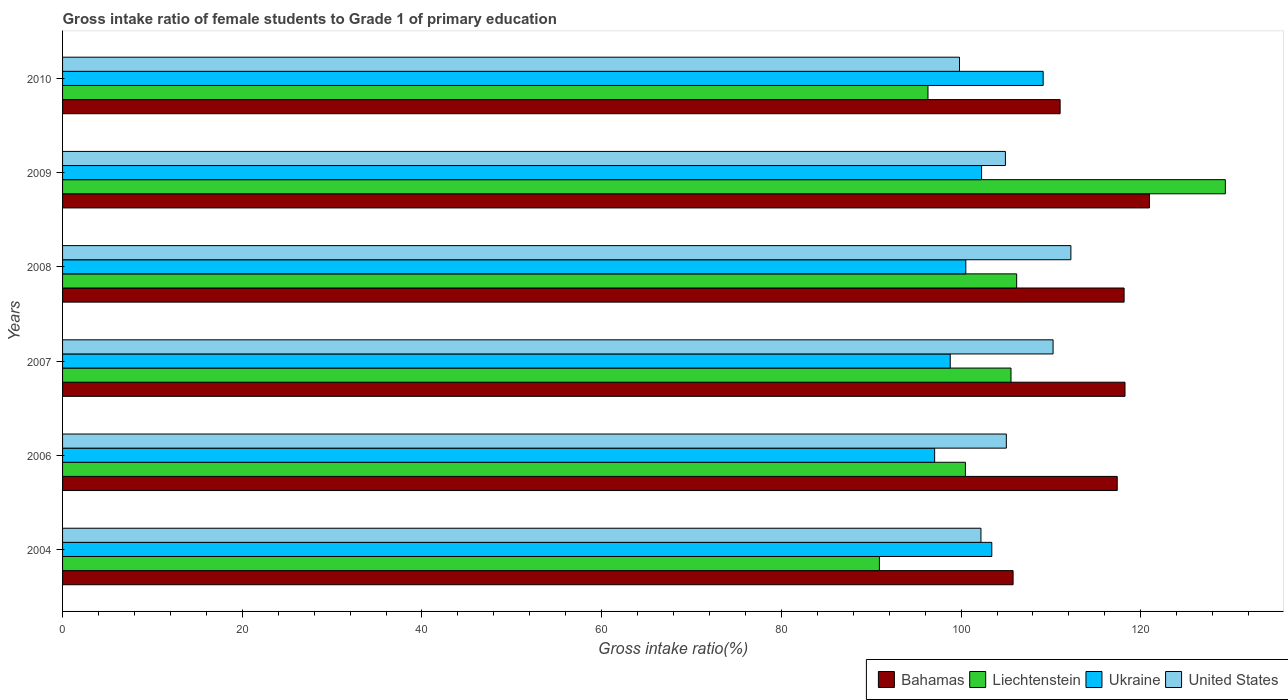How many groups of bars are there?
Your response must be concise. 6. Are the number of bars per tick equal to the number of legend labels?
Provide a short and direct response. Yes. What is the gross intake ratio in Bahamas in 2009?
Your answer should be very brief. 120.97. Across all years, what is the maximum gross intake ratio in Bahamas?
Make the answer very short. 120.97. Across all years, what is the minimum gross intake ratio in United States?
Give a very brief answer. 99.82. What is the total gross intake ratio in Ukraine in the graph?
Offer a very short reply. 611.21. What is the difference between the gross intake ratio in Bahamas in 2004 and that in 2008?
Offer a terse response. -12.35. What is the difference between the gross intake ratio in Ukraine in 2009 and the gross intake ratio in United States in 2008?
Ensure brevity in your answer.  -9.94. What is the average gross intake ratio in United States per year?
Offer a very short reply. 105.74. In the year 2010, what is the difference between the gross intake ratio in Liechtenstein and gross intake ratio in United States?
Offer a terse response. -3.51. What is the ratio of the gross intake ratio in Liechtenstein in 2009 to that in 2010?
Your answer should be compact. 1.34. Is the gross intake ratio in Bahamas in 2006 less than that in 2009?
Keep it short and to the point. Yes. Is the difference between the gross intake ratio in Liechtenstein in 2007 and 2010 greater than the difference between the gross intake ratio in United States in 2007 and 2010?
Give a very brief answer. No. What is the difference between the highest and the second highest gross intake ratio in Ukraine?
Your answer should be very brief. 5.72. What is the difference between the highest and the lowest gross intake ratio in Ukraine?
Keep it short and to the point. 12.08. Is it the case that in every year, the sum of the gross intake ratio in Bahamas and gross intake ratio in Liechtenstein is greater than the sum of gross intake ratio in United States and gross intake ratio in Ukraine?
Your answer should be compact. No. What does the 2nd bar from the top in 2007 represents?
Keep it short and to the point. Ukraine. What does the 3rd bar from the bottom in 2007 represents?
Provide a short and direct response. Ukraine. Is it the case that in every year, the sum of the gross intake ratio in Liechtenstein and gross intake ratio in United States is greater than the gross intake ratio in Bahamas?
Provide a short and direct response. Yes. How many bars are there?
Ensure brevity in your answer.  24. Are all the bars in the graph horizontal?
Give a very brief answer. Yes. Does the graph contain any zero values?
Your response must be concise. No. How many legend labels are there?
Make the answer very short. 4. How are the legend labels stacked?
Your response must be concise. Horizontal. What is the title of the graph?
Offer a very short reply. Gross intake ratio of female students to Grade 1 of primary education. What is the label or title of the X-axis?
Provide a succinct answer. Gross intake ratio(%). What is the label or title of the Y-axis?
Your answer should be compact. Years. What is the Gross intake ratio(%) in Bahamas in 2004?
Give a very brief answer. 105.79. What is the Gross intake ratio(%) of Liechtenstein in 2004?
Provide a short and direct response. 90.91. What is the Gross intake ratio(%) in Ukraine in 2004?
Offer a terse response. 103.42. What is the Gross intake ratio(%) in United States in 2004?
Your answer should be compact. 102.21. What is the Gross intake ratio(%) of Bahamas in 2006?
Offer a terse response. 117.38. What is the Gross intake ratio(%) of Liechtenstein in 2006?
Offer a very short reply. 100.48. What is the Gross intake ratio(%) in Ukraine in 2006?
Keep it short and to the point. 97.06. What is the Gross intake ratio(%) of United States in 2006?
Your answer should be very brief. 105.04. What is the Gross intake ratio(%) in Bahamas in 2007?
Your answer should be very brief. 118.24. What is the Gross intake ratio(%) of Liechtenstein in 2007?
Offer a very short reply. 105.56. What is the Gross intake ratio(%) of Ukraine in 2007?
Provide a short and direct response. 98.79. What is the Gross intake ratio(%) of United States in 2007?
Your answer should be compact. 110.24. What is the Gross intake ratio(%) in Bahamas in 2008?
Offer a terse response. 118.14. What is the Gross intake ratio(%) in Liechtenstein in 2008?
Provide a succinct answer. 106.19. What is the Gross intake ratio(%) in Ukraine in 2008?
Keep it short and to the point. 100.53. What is the Gross intake ratio(%) of United States in 2008?
Offer a very short reply. 112.22. What is the Gross intake ratio(%) in Bahamas in 2009?
Make the answer very short. 120.97. What is the Gross intake ratio(%) of Liechtenstein in 2009?
Your answer should be compact. 129.41. What is the Gross intake ratio(%) in Ukraine in 2009?
Provide a short and direct response. 102.28. What is the Gross intake ratio(%) of United States in 2009?
Make the answer very short. 104.94. What is the Gross intake ratio(%) of Bahamas in 2010?
Make the answer very short. 111.02. What is the Gross intake ratio(%) in Liechtenstein in 2010?
Provide a short and direct response. 96.32. What is the Gross intake ratio(%) of Ukraine in 2010?
Provide a short and direct response. 109.14. What is the Gross intake ratio(%) of United States in 2010?
Offer a terse response. 99.82. Across all years, what is the maximum Gross intake ratio(%) in Bahamas?
Your answer should be compact. 120.97. Across all years, what is the maximum Gross intake ratio(%) in Liechtenstein?
Keep it short and to the point. 129.41. Across all years, what is the maximum Gross intake ratio(%) of Ukraine?
Make the answer very short. 109.14. Across all years, what is the maximum Gross intake ratio(%) in United States?
Your answer should be compact. 112.22. Across all years, what is the minimum Gross intake ratio(%) of Bahamas?
Offer a terse response. 105.79. Across all years, what is the minimum Gross intake ratio(%) in Liechtenstein?
Provide a short and direct response. 90.91. Across all years, what is the minimum Gross intake ratio(%) of Ukraine?
Ensure brevity in your answer.  97.06. Across all years, what is the minimum Gross intake ratio(%) in United States?
Give a very brief answer. 99.82. What is the total Gross intake ratio(%) of Bahamas in the graph?
Offer a very short reply. 691.54. What is the total Gross intake ratio(%) of Liechtenstein in the graph?
Give a very brief answer. 628.86. What is the total Gross intake ratio(%) of Ukraine in the graph?
Keep it short and to the point. 611.21. What is the total Gross intake ratio(%) of United States in the graph?
Give a very brief answer. 634.47. What is the difference between the Gross intake ratio(%) in Bahamas in 2004 and that in 2006?
Your answer should be very brief. -11.59. What is the difference between the Gross intake ratio(%) in Liechtenstein in 2004 and that in 2006?
Your response must be concise. -9.57. What is the difference between the Gross intake ratio(%) of Ukraine in 2004 and that in 2006?
Your answer should be very brief. 6.36. What is the difference between the Gross intake ratio(%) in United States in 2004 and that in 2006?
Provide a short and direct response. -2.82. What is the difference between the Gross intake ratio(%) in Bahamas in 2004 and that in 2007?
Offer a terse response. -12.46. What is the difference between the Gross intake ratio(%) in Liechtenstein in 2004 and that in 2007?
Your response must be concise. -14.65. What is the difference between the Gross intake ratio(%) in Ukraine in 2004 and that in 2007?
Provide a short and direct response. 4.63. What is the difference between the Gross intake ratio(%) in United States in 2004 and that in 2007?
Provide a short and direct response. -8.03. What is the difference between the Gross intake ratio(%) in Bahamas in 2004 and that in 2008?
Provide a succinct answer. -12.36. What is the difference between the Gross intake ratio(%) in Liechtenstein in 2004 and that in 2008?
Your answer should be very brief. -15.28. What is the difference between the Gross intake ratio(%) of Ukraine in 2004 and that in 2008?
Provide a short and direct response. 2.89. What is the difference between the Gross intake ratio(%) in United States in 2004 and that in 2008?
Make the answer very short. -10.01. What is the difference between the Gross intake ratio(%) in Bahamas in 2004 and that in 2009?
Your answer should be compact. -15.18. What is the difference between the Gross intake ratio(%) in Liechtenstein in 2004 and that in 2009?
Your response must be concise. -38.5. What is the difference between the Gross intake ratio(%) in Ukraine in 2004 and that in 2009?
Give a very brief answer. 1.14. What is the difference between the Gross intake ratio(%) of United States in 2004 and that in 2009?
Give a very brief answer. -2.72. What is the difference between the Gross intake ratio(%) of Bahamas in 2004 and that in 2010?
Give a very brief answer. -5.24. What is the difference between the Gross intake ratio(%) of Liechtenstein in 2004 and that in 2010?
Keep it short and to the point. -5.41. What is the difference between the Gross intake ratio(%) in Ukraine in 2004 and that in 2010?
Your answer should be compact. -5.72. What is the difference between the Gross intake ratio(%) in United States in 2004 and that in 2010?
Your response must be concise. 2.39. What is the difference between the Gross intake ratio(%) of Bahamas in 2006 and that in 2007?
Give a very brief answer. -0.87. What is the difference between the Gross intake ratio(%) of Liechtenstein in 2006 and that in 2007?
Give a very brief answer. -5.07. What is the difference between the Gross intake ratio(%) in Ukraine in 2006 and that in 2007?
Give a very brief answer. -1.74. What is the difference between the Gross intake ratio(%) of United States in 2006 and that in 2007?
Keep it short and to the point. -5.2. What is the difference between the Gross intake ratio(%) in Bahamas in 2006 and that in 2008?
Your response must be concise. -0.76. What is the difference between the Gross intake ratio(%) in Liechtenstein in 2006 and that in 2008?
Provide a succinct answer. -5.7. What is the difference between the Gross intake ratio(%) in Ukraine in 2006 and that in 2008?
Give a very brief answer. -3.47. What is the difference between the Gross intake ratio(%) of United States in 2006 and that in 2008?
Make the answer very short. -7.18. What is the difference between the Gross intake ratio(%) in Bahamas in 2006 and that in 2009?
Your answer should be very brief. -3.59. What is the difference between the Gross intake ratio(%) of Liechtenstein in 2006 and that in 2009?
Offer a very short reply. -28.93. What is the difference between the Gross intake ratio(%) in Ukraine in 2006 and that in 2009?
Your response must be concise. -5.23. What is the difference between the Gross intake ratio(%) of United States in 2006 and that in 2009?
Your answer should be compact. 0.1. What is the difference between the Gross intake ratio(%) of Bahamas in 2006 and that in 2010?
Your response must be concise. 6.35. What is the difference between the Gross intake ratio(%) in Liechtenstein in 2006 and that in 2010?
Make the answer very short. 4.17. What is the difference between the Gross intake ratio(%) of Ukraine in 2006 and that in 2010?
Offer a terse response. -12.08. What is the difference between the Gross intake ratio(%) of United States in 2006 and that in 2010?
Your response must be concise. 5.21. What is the difference between the Gross intake ratio(%) in Bahamas in 2007 and that in 2008?
Provide a succinct answer. 0.1. What is the difference between the Gross intake ratio(%) in Liechtenstein in 2007 and that in 2008?
Make the answer very short. -0.63. What is the difference between the Gross intake ratio(%) of Ukraine in 2007 and that in 2008?
Make the answer very short. -1.73. What is the difference between the Gross intake ratio(%) in United States in 2007 and that in 2008?
Offer a terse response. -1.98. What is the difference between the Gross intake ratio(%) of Bahamas in 2007 and that in 2009?
Your answer should be very brief. -2.72. What is the difference between the Gross intake ratio(%) in Liechtenstein in 2007 and that in 2009?
Provide a short and direct response. -23.86. What is the difference between the Gross intake ratio(%) in Ukraine in 2007 and that in 2009?
Offer a very short reply. -3.49. What is the difference between the Gross intake ratio(%) of United States in 2007 and that in 2009?
Provide a succinct answer. 5.3. What is the difference between the Gross intake ratio(%) in Bahamas in 2007 and that in 2010?
Give a very brief answer. 7.22. What is the difference between the Gross intake ratio(%) of Liechtenstein in 2007 and that in 2010?
Give a very brief answer. 9.24. What is the difference between the Gross intake ratio(%) of Ukraine in 2007 and that in 2010?
Your answer should be very brief. -10.34. What is the difference between the Gross intake ratio(%) in United States in 2007 and that in 2010?
Provide a short and direct response. 10.41. What is the difference between the Gross intake ratio(%) in Bahamas in 2008 and that in 2009?
Give a very brief answer. -2.82. What is the difference between the Gross intake ratio(%) in Liechtenstein in 2008 and that in 2009?
Provide a succinct answer. -23.23. What is the difference between the Gross intake ratio(%) in Ukraine in 2008 and that in 2009?
Offer a terse response. -1.75. What is the difference between the Gross intake ratio(%) in United States in 2008 and that in 2009?
Provide a succinct answer. 7.29. What is the difference between the Gross intake ratio(%) of Bahamas in 2008 and that in 2010?
Give a very brief answer. 7.12. What is the difference between the Gross intake ratio(%) of Liechtenstein in 2008 and that in 2010?
Offer a terse response. 9.87. What is the difference between the Gross intake ratio(%) of Ukraine in 2008 and that in 2010?
Provide a succinct answer. -8.61. What is the difference between the Gross intake ratio(%) of United States in 2008 and that in 2010?
Your response must be concise. 12.4. What is the difference between the Gross intake ratio(%) in Bahamas in 2009 and that in 2010?
Your answer should be compact. 9.94. What is the difference between the Gross intake ratio(%) of Liechtenstein in 2009 and that in 2010?
Your answer should be very brief. 33.1. What is the difference between the Gross intake ratio(%) in Ukraine in 2009 and that in 2010?
Offer a terse response. -6.85. What is the difference between the Gross intake ratio(%) in United States in 2009 and that in 2010?
Keep it short and to the point. 5.11. What is the difference between the Gross intake ratio(%) of Bahamas in 2004 and the Gross intake ratio(%) of Liechtenstein in 2006?
Your answer should be compact. 5.3. What is the difference between the Gross intake ratio(%) in Bahamas in 2004 and the Gross intake ratio(%) in Ukraine in 2006?
Your answer should be compact. 8.73. What is the difference between the Gross intake ratio(%) in Bahamas in 2004 and the Gross intake ratio(%) in United States in 2006?
Provide a succinct answer. 0.75. What is the difference between the Gross intake ratio(%) in Liechtenstein in 2004 and the Gross intake ratio(%) in Ukraine in 2006?
Make the answer very short. -6.15. What is the difference between the Gross intake ratio(%) of Liechtenstein in 2004 and the Gross intake ratio(%) of United States in 2006?
Your answer should be compact. -14.13. What is the difference between the Gross intake ratio(%) in Ukraine in 2004 and the Gross intake ratio(%) in United States in 2006?
Provide a short and direct response. -1.62. What is the difference between the Gross intake ratio(%) of Bahamas in 2004 and the Gross intake ratio(%) of Liechtenstein in 2007?
Give a very brief answer. 0.23. What is the difference between the Gross intake ratio(%) of Bahamas in 2004 and the Gross intake ratio(%) of Ukraine in 2007?
Your response must be concise. 6.99. What is the difference between the Gross intake ratio(%) of Bahamas in 2004 and the Gross intake ratio(%) of United States in 2007?
Offer a very short reply. -4.45. What is the difference between the Gross intake ratio(%) of Liechtenstein in 2004 and the Gross intake ratio(%) of Ukraine in 2007?
Offer a very short reply. -7.88. What is the difference between the Gross intake ratio(%) in Liechtenstein in 2004 and the Gross intake ratio(%) in United States in 2007?
Your answer should be very brief. -19.33. What is the difference between the Gross intake ratio(%) in Ukraine in 2004 and the Gross intake ratio(%) in United States in 2007?
Ensure brevity in your answer.  -6.82. What is the difference between the Gross intake ratio(%) in Bahamas in 2004 and the Gross intake ratio(%) in Liechtenstein in 2008?
Ensure brevity in your answer.  -0.4. What is the difference between the Gross intake ratio(%) of Bahamas in 2004 and the Gross intake ratio(%) of Ukraine in 2008?
Offer a terse response. 5.26. What is the difference between the Gross intake ratio(%) in Bahamas in 2004 and the Gross intake ratio(%) in United States in 2008?
Keep it short and to the point. -6.43. What is the difference between the Gross intake ratio(%) in Liechtenstein in 2004 and the Gross intake ratio(%) in Ukraine in 2008?
Offer a terse response. -9.62. What is the difference between the Gross intake ratio(%) of Liechtenstein in 2004 and the Gross intake ratio(%) of United States in 2008?
Keep it short and to the point. -21.31. What is the difference between the Gross intake ratio(%) of Ukraine in 2004 and the Gross intake ratio(%) of United States in 2008?
Your answer should be very brief. -8.8. What is the difference between the Gross intake ratio(%) of Bahamas in 2004 and the Gross intake ratio(%) of Liechtenstein in 2009?
Your answer should be very brief. -23.62. What is the difference between the Gross intake ratio(%) of Bahamas in 2004 and the Gross intake ratio(%) of Ukraine in 2009?
Your answer should be very brief. 3.51. What is the difference between the Gross intake ratio(%) of Bahamas in 2004 and the Gross intake ratio(%) of United States in 2009?
Your answer should be very brief. 0.85. What is the difference between the Gross intake ratio(%) of Liechtenstein in 2004 and the Gross intake ratio(%) of Ukraine in 2009?
Your answer should be compact. -11.37. What is the difference between the Gross intake ratio(%) in Liechtenstein in 2004 and the Gross intake ratio(%) in United States in 2009?
Provide a short and direct response. -14.03. What is the difference between the Gross intake ratio(%) in Ukraine in 2004 and the Gross intake ratio(%) in United States in 2009?
Your answer should be compact. -1.52. What is the difference between the Gross intake ratio(%) of Bahamas in 2004 and the Gross intake ratio(%) of Liechtenstein in 2010?
Your answer should be compact. 9.47. What is the difference between the Gross intake ratio(%) in Bahamas in 2004 and the Gross intake ratio(%) in Ukraine in 2010?
Offer a very short reply. -3.35. What is the difference between the Gross intake ratio(%) in Bahamas in 2004 and the Gross intake ratio(%) in United States in 2010?
Offer a very short reply. 5.96. What is the difference between the Gross intake ratio(%) in Liechtenstein in 2004 and the Gross intake ratio(%) in Ukraine in 2010?
Provide a short and direct response. -18.23. What is the difference between the Gross intake ratio(%) in Liechtenstein in 2004 and the Gross intake ratio(%) in United States in 2010?
Your answer should be very brief. -8.91. What is the difference between the Gross intake ratio(%) in Ukraine in 2004 and the Gross intake ratio(%) in United States in 2010?
Your answer should be very brief. 3.6. What is the difference between the Gross intake ratio(%) in Bahamas in 2006 and the Gross intake ratio(%) in Liechtenstein in 2007?
Your answer should be compact. 11.82. What is the difference between the Gross intake ratio(%) of Bahamas in 2006 and the Gross intake ratio(%) of Ukraine in 2007?
Offer a very short reply. 18.58. What is the difference between the Gross intake ratio(%) of Bahamas in 2006 and the Gross intake ratio(%) of United States in 2007?
Offer a terse response. 7.14. What is the difference between the Gross intake ratio(%) of Liechtenstein in 2006 and the Gross intake ratio(%) of Ukraine in 2007?
Make the answer very short. 1.69. What is the difference between the Gross intake ratio(%) of Liechtenstein in 2006 and the Gross intake ratio(%) of United States in 2007?
Your response must be concise. -9.76. What is the difference between the Gross intake ratio(%) in Ukraine in 2006 and the Gross intake ratio(%) in United States in 2007?
Offer a very short reply. -13.18. What is the difference between the Gross intake ratio(%) of Bahamas in 2006 and the Gross intake ratio(%) of Liechtenstein in 2008?
Keep it short and to the point. 11.19. What is the difference between the Gross intake ratio(%) of Bahamas in 2006 and the Gross intake ratio(%) of Ukraine in 2008?
Offer a very short reply. 16.85. What is the difference between the Gross intake ratio(%) of Bahamas in 2006 and the Gross intake ratio(%) of United States in 2008?
Offer a very short reply. 5.16. What is the difference between the Gross intake ratio(%) in Liechtenstein in 2006 and the Gross intake ratio(%) in Ukraine in 2008?
Offer a terse response. -0.04. What is the difference between the Gross intake ratio(%) of Liechtenstein in 2006 and the Gross intake ratio(%) of United States in 2008?
Provide a short and direct response. -11.74. What is the difference between the Gross intake ratio(%) in Ukraine in 2006 and the Gross intake ratio(%) in United States in 2008?
Your answer should be very brief. -15.16. What is the difference between the Gross intake ratio(%) in Bahamas in 2006 and the Gross intake ratio(%) in Liechtenstein in 2009?
Offer a very short reply. -12.03. What is the difference between the Gross intake ratio(%) in Bahamas in 2006 and the Gross intake ratio(%) in Ukraine in 2009?
Give a very brief answer. 15.1. What is the difference between the Gross intake ratio(%) of Bahamas in 2006 and the Gross intake ratio(%) of United States in 2009?
Offer a very short reply. 12.44. What is the difference between the Gross intake ratio(%) in Liechtenstein in 2006 and the Gross intake ratio(%) in Ukraine in 2009?
Keep it short and to the point. -1.8. What is the difference between the Gross intake ratio(%) in Liechtenstein in 2006 and the Gross intake ratio(%) in United States in 2009?
Give a very brief answer. -4.45. What is the difference between the Gross intake ratio(%) of Ukraine in 2006 and the Gross intake ratio(%) of United States in 2009?
Your response must be concise. -7.88. What is the difference between the Gross intake ratio(%) in Bahamas in 2006 and the Gross intake ratio(%) in Liechtenstein in 2010?
Provide a succinct answer. 21.06. What is the difference between the Gross intake ratio(%) of Bahamas in 2006 and the Gross intake ratio(%) of Ukraine in 2010?
Your answer should be compact. 8.24. What is the difference between the Gross intake ratio(%) of Bahamas in 2006 and the Gross intake ratio(%) of United States in 2010?
Keep it short and to the point. 17.55. What is the difference between the Gross intake ratio(%) in Liechtenstein in 2006 and the Gross intake ratio(%) in Ukraine in 2010?
Ensure brevity in your answer.  -8.65. What is the difference between the Gross intake ratio(%) in Liechtenstein in 2006 and the Gross intake ratio(%) in United States in 2010?
Ensure brevity in your answer.  0.66. What is the difference between the Gross intake ratio(%) in Ukraine in 2006 and the Gross intake ratio(%) in United States in 2010?
Your answer should be compact. -2.77. What is the difference between the Gross intake ratio(%) in Bahamas in 2007 and the Gross intake ratio(%) in Liechtenstein in 2008?
Provide a short and direct response. 12.06. What is the difference between the Gross intake ratio(%) in Bahamas in 2007 and the Gross intake ratio(%) in Ukraine in 2008?
Ensure brevity in your answer.  17.72. What is the difference between the Gross intake ratio(%) in Bahamas in 2007 and the Gross intake ratio(%) in United States in 2008?
Keep it short and to the point. 6.02. What is the difference between the Gross intake ratio(%) in Liechtenstein in 2007 and the Gross intake ratio(%) in Ukraine in 2008?
Provide a succinct answer. 5.03. What is the difference between the Gross intake ratio(%) in Liechtenstein in 2007 and the Gross intake ratio(%) in United States in 2008?
Ensure brevity in your answer.  -6.67. What is the difference between the Gross intake ratio(%) of Ukraine in 2007 and the Gross intake ratio(%) of United States in 2008?
Offer a terse response. -13.43. What is the difference between the Gross intake ratio(%) in Bahamas in 2007 and the Gross intake ratio(%) in Liechtenstein in 2009?
Give a very brief answer. -11.17. What is the difference between the Gross intake ratio(%) of Bahamas in 2007 and the Gross intake ratio(%) of Ukraine in 2009?
Give a very brief answer. 15.96. What is the difference between the Gross intake ratio(%) of Bahamas in 2007 and the Gross intake ratio(%) of United States in 2009?
Your answer should be compact. 13.31. What is the difference between the Gross intake ratio(%) of Liechtenstein in 2007 and the Gross intake ratio(%) of Ukraine in 2009?
Make the answer very short. 3.27. What is the difference between the Gross intake ratio(%) in Liechtenstein in 2007 and the Gross intake ratio(%) in United States in 2009?
Keep it short and to the point. 0.62. What is the difference between the Gross intake ratio(%) of Ukraine in 2007 and the Gross intake ratio(%) of United States in 2009?
Make the answer very short. -6.14. What is the difference between the Gross intake ratio(%) in Bahamas in 2007 and the Gross intake ratio(%) in Liechtenstein in 2010?
Your response must be concise. 21.93. What is the difference between the Gross intake ratio(%) in Bahamas in 2007 and the Gross intake ratio(%) in Ukraine in 2010?
Make the answer very short. 9.11. What is the difference between the Gross intake ratio(%) of Bahamas in 2007 and the Gross intake ratio(%) of United States in 2010?
Ensure brevity in your answer.  18.42. What is the difference between the Gross intake ratio(%) in Liechtenstein in 2007 and the Gross intake ratio(%) in Ukraine in 2010?
Provide a short and direct response. -3.58. What is the difference between the Gross intake ratio(%) of Liechtenstein in 2007 and the Gross intake ratio(%) of United States in 2010?
Your answer should be compact. 5.73. What is the difference between the Gross intake ratio(%) in Ukraine in 2007 and the Gross intake ratio(%) in United States in 2010?
Make the answer very short. -1.03. What is the difference between the Gross intake ratio(%) of Bahamas in 2008 and the Gross intake ratio(%) of Liechtenstein in 2009?
Offer a very short reply. -11.27. What is the difference between the Gross intake ratio(%) of Bahamas in 2008 and the Gross intake ratio(%) of Ukraine in 2009?
Your answer should be compact. 15.86. What is the difference between the Gross intake ratio(%) in Bahamas in 2008 and the Gross intake ratio(%) in United States in 2009?
Your answer should be compact. 13.21. What is the difference between the Gross intake ratio(%) of Liechtenstein in 2008 and the Gross intake ratio(%) of Ukraine in 2009?
Provide a succinct answer. 3.9. What is the difference between the Gross intake ratio(%) of Liechtenstein in 2008 and the Gross intake ratio(%) of United States in 2009?
Keep it short and to the point. 1.25. What is the difference between the Gross intake ratio(%) in Ukraine in 2008 and the Gross intake ratio(%) in United States in 2009?
Give a very brief answer. -4.41. What is the difference between the Gross intake ratio(%) of Bahamas in 2008 and the Gross intake ratio(%) of Liechtenstein in 2010?
Make the answer very short. 21.83. What is the difference between the Gross intake ratio(%) of Bahamas in 2008 and the Gross intake ratio(%) of Ukraine in 2010?
Your answer should be compact. 9.01. What is the difference between the Gross intake ratio(%) of Bahamas in 2008 and the Gross intake ratio(%) of United States in 2010?
Your answer should be compact. 18.32. What is the difference between the Gross intake ratio(%) of Liechtenstein in 2008 and the Gross intake ratio(%) of Ukraine in 2010?
Provide a short and direct response. -2.95. What is the difference between the Gross intake ratio(%) of Liechtenstein in 2008 and the Gross intake ratio(%) of United States in 2010?
Make the answer very short. 6.36. What is the difference between the Gross intake ratio(%) in Ukraine in 2008 and the Gross intake ratio(%) in United States in 2010?
Provide a succinct answer. 0.7. What is the difference between the Gross intake ratio(%) of Bahamas in 2009 and the Gross intake ratio(%) of Liechtenstein in 2010?
Provide a short and direct response. 24.65. What is the difference between the Gross intake ratio(%) in Bahamas in 2009 and the Gross intake ratio(%) in Ukraine in 2010?
Make the answer very short. 11.83. What is the difference between the Gross intake ratio(%) in Bahamas in 2009 and the Gross intake ratio(%) in United States in 2010?
Your answer should be very brief. 21.14. What is the difference between the Gross intake ratio(%) of Liechtenstein in 2009 and the Gross intake ratio(%) of Ukraine in 2010?
Your answer should be compact. 20.28. What is the difference between the Gross intake ratio(%) in Liechtenstein in 2009 and the Gross intake ratio(%) in United States in 2010?
Offer a terse response. 29.59. What is the difference between the Gross intake ratio(%) of Ukraine in 2009 and the Gross intake ratio(%) of United States in 2010?
Provide a short and direct response. 2.46. What is the average Gross intake ratio(%) in Bahamas per year?
Offer a very short reply. 115.26. What is the average Gross intake ratio(%) in Liechtenstein per year?
Ensure brevity in your answer.  104.81. What is the average Gross intake ratio(%) of Ukraine per year?
Keep it short and to the point. 101.87. What is the average Gross intake ratio(%) in United States per year?
Your answer should be very brief. 105.74. In the year 2004, what is the difference between the Gross intake ratio(%) of Bahamas and Gross intake ratio(%) of Liechtenstein?
Make the answer very short. 14.88. In the year 2004, what is the difference between the Gross intake ratio(%) of Bahamas and Gross intake ratio(%) of Ukraine?
Keep it short and to the point. 2.37. In the year 2004, what is the difference between the Gross intake ratio(%) of Bahamas and Gross intake ratio(%) of United States?
Keep it short and to the point. 3.58. In the year 2004, what is the difference between the Gross intake ratio(%) of Liechtenstein and Gross intake ratio(%) of Ukraine?
Keep it short and to the point. -12.51. In the year 2004, what is the difference between the Gross intake ratio(%) of Liechtenstein and Gross intake ratio(%) of United States?
Your response must be concise. -11.3. In the year 2004, what is the difference between the Gross intake ratio(%) of Ukraine and Gross intake ratio(%) of United States?
Offer a terse response. 1.21. In the year 2006, what is the difference between the Gross intake ratio(%) of Bahamas and Gross intake ratio(%) of Liechtenstein?
Make the answer very short. 16.9. In the year 2006, what is the difference between the Gross intake ratio(%) in Bahamas and Gross intake ratio(%) in Ukraine?
Give a very brief answer. 20.32. In the year 2006, what is the difference between the Gross intake ratio(%) of Bahamas and Gross intake ratio(%) of United States?
Make the answer very short. 12.34. In the year 2006, what is the difference between the Gross intake ratio(%) in Liechtenstein and Gross intake ratio(%) in Ukraine?
Provide a succinct answer. 3.43. In the year 2006, what is the difference between the Gross intake ratio(%) of Liechtenstein and Gross intake ratio(%) of United States?
Provide a succinct answer. -4.55. In the year 2006, what is the difference between the Gross intake ratio(%) in Ukraine and Gross intake ratio(%) in United States?
Your answer should be very brief. -7.98. In the year 2007, what is the difference between the Gross intake ratio(%) in Bahamas and Gross intake ratio(%) in Liechtenstein?
Your answer should be compact. 12.69. In the year 2007, what is the difference between the Gross intake ratio(%) in Bahamas and Gross intake ratio(%) in Ukraine?
Ensure brevity in your answer.  19.45. In the year 2007, what is the difference between the Gross intake ratio(%) of Bahamas and Gross intake ratio(%) of United States?
Offer a very short reply. 8.01. In the year 2007, what is the difference between the Gross intake ratio(%) in Liechtenstein and Gross intake ratio(%) in Ukraine?
Ensure brevity in your answer.  6.76. In the year 2007, what is the difference between the Gross intake ratio(%) in Liechtenstein and Gross intake ratio(%) in United States?
Your answer should be very brief. -4.68. In the year 2007, what is the difference between the Gross intake ratio(%) of Ukraine and Gross intake ratio(%) of United States?
Give a very brief answer. -11.45. In the year 2008, what is the difference between the Gross intake ratio(%) of Bahamas and Gross intake ratio(%) of Liechtenstein?
Provide a short and direct response. 11.96. In the year 2008, what is the difference between the Gross intake ratio(%) in Bahamas and Gross intake ratio(%) in Ukraine?
Offer a terse response. 17.62. In the year 2008, what is the difference between the Gross intake ratio(%) of Bahamas and Gross intake ratio(%) of United States?
Keep it short and to the point. 5.92. In the year 2008, what is the difference between the Gross intake ratio(%) in Liechtenstein and Gross intake ratio(%) in Ukraine?
Offer a terse response. 5.66. In the year 2008, what is the difference between the Gross intake ratio(%) in Liechtenstein and Gross intake ratio(%) in United States?
Your response must be concise. -6.04. In the year 2008, what is the difference between the Gross intake ratio(%) of Ukraine and Gross intake ratio(%) of United States?
Provide a short and direct response. -11.69. In the year 2009, what is the difference between the Gross intake ratio(%) of Bahamas and Gross intake ratio(%) of Liechtenstein?
Your answer should be very brief. -8.45. In the year 2009, what is the difference between the Gross intake ratio(%) of Bahamas and Gross intake ratio(%) of Ukraine?
Your response must be concise. 18.68. In the year 2009, what is the difference between the Gross intake ratio(%) in Bahamas and Gross intake ratio(%) in United States?
Provide a short and direct response. 16.03. In the year 2009, what is the difference between the Gross intake ratio(%) of Liechtenstein and Gross intake ratio(%) of Ukraine?
Keep it short and to the point. 27.13. In the year 2009, what is the difference between the Gross intake ratio(%) in Liechtenstein and Gross intake ratio(%) in United States?
Your answer should be very brief. 24.48. In the year 2009, what is the difference between the Gross intake ratio(%) of Ukraine and Gross intake ratio(%) of United States?
Provide a succinct answer. -2.65. In the year 2010, what is the difference between the Gross intake ratio(%) in Bahamas and Gross intake ratio(%) in Liechtenstein?
Your answer should be very brief. 14.71. In the year 2010, what is the difference between the Gross intake ratio(%) of Bahamas and Gross intake ratio(%) of Ukraine?
Provide a succinct answer. 1.89. In the year 2010, what is the difference between the Gross intake ratio(%) in Bahamas and Gross intake ratio(%) in United States?
Your answer should be very brief. 11.2. In the year 2010, what is the difference between the Gross intake ratio(%) of Liechtenstein and Gross intake ratio(%) of Ukraine?
Provide a succinct answer. -12.82. In the year 2010, what is the difference between the Gross intake ratio(%) of Liechtenstein and Gross intake ratio(%) of United States?
Provide a short and direct response. -3.51. In the year 2010, what is the difference between the Gross intake ratio(%) in Ukraine and Gross intake ratio(%) in United States?
Make the answer very short. 9.31. What is the ratio of the Gross intake ratio(%) in Bahamas in 2004 to that in 2006?
Keep it short and to the point. 0.9. What is the ratio of the Gross intake ratio(%) in Liechtenstein in 2004 to that in 2006?
Keep it short and to the point. 0.9. What is the ratio of the Gross intake ratio(%) of Ukraine in 2004 to that in 2006?
Provide a short and direct response. 1.07. What is the ratio of the Gross intake ratio(%) of United States in 2004 to that in 2006?
Your response must be concise. 0.97. What is the ratio of the Gross intake ratio(%) in Bahamas in 2004 to that in 2007?
Give a very brief answer. 0.89. What is the ratio of the Gross intake ratio(%) in Liechtenstein in 2004 to that in 2007?
Give a very brief answer. 0.86. What is the ratio of the Gross intake ratio(%) of Ukraine in 2004 to that in 2007?
Provide a short and direct response. 1.05. What is the ratio of the Gross intake ratio(%) in United States in 2004 to that in 2007?
Your response must be concise. 0.93. What is the ratio of the Gross intake ratio(%) of Bahamas in 2004 to that in 2008?
Provide a short and direct response. 0.9. What is the ratio of the Gross intake ratio(%) of Liechtenstein in 2004 to that in 2008?
Provide a short and direct response. 0.86. What is the ratio of the Gross intake ratio(%) of Ukraine in 2004 to that in 2008?
Provide a short and direct response. 1.03. What is the ratio of the Gross intake ratio(%) in United States in 2004 to that in 2008?
Offer a terse response. 0.91. What is the ratio of the Gross intake ratio(%) of Bahamas in 2004 to that in 2009?
Your answer should be compact. 0.87. What is the ratio of the Gross intake ratio(%) of Liechtenstein in 2004 to that in 2009?
Your response must be concise. 0.7. What is the ratio of the Gross intake ratio(%) in Ukraine in 2004 to that in 2009?
Offer a terse response. 1.01. What is the ratio of the Gross intake ratio(%) in United States in 2004 to that in 2009?
Offer a very short reply. 0.97. What is the ratio of the Gross intake ratio(%) in Bahamas in 2004 to that in 2010?
Make the answer very short. 0.95. What is the ratio of the Gross intake ratio(%) in Liechtenstein in 2004 to that in 2010?
Your answer should be compact. 0.94. What is the ratio of the Gross intake ratio(%) of Ukraine in 2004 to that in 2010?
Provide a short and direct response. 0.95. What is the ratio of the Gross intake ratio(%) in United States in 2004 to that in 2010?
Your response must be concise. 1.02. What is the ratio of the Gross intake ratio(%) of Liechtenstein in 2006 to that in 2007?
Keep it short and to the point. 0.95. What is the ratio of the Gross intake ratio(%) of Ukraine in 2006 to that in 2007?
Make the answer very short. 0.98. What is the ratio of the Gross intake ratio(%) in United States in 2006 to that in 2007?
Your answer should be compact. 0.95. What is the ratio of the Gross intake ratio(%) of Liechtenstein in 2006 to that in 2008?
Your answer should be very brief. 0.95. What is the ratio of the Gross intake ratio(%) in Ukraine in 2006 to that in 2008?
Make the answer very short. 0.97. What is the ratio of the Gross intake ratio(%) in United States in 2006 to that in 2008?
Provide a short and direct response. 0.94. What is the ratio of the Gross intake ratio(%) of Bahamas in 2006 to that in 2009?
Give a very brief answer. 0.97. What is the ratio of the Gross intake ratio(%) in Liechtenstein in 2006 to that in 2009?
Provide a succinct answer. 0.78. What is the ratio of the Gross intake ratio(%) in Ukraine in 2006 to that in 2009?
Make the answer very short. 0.95. What is the ratio of the Gross intake ratio(%) of United States in 2006 to that in 2009?
Give a very brief answer. 1. What is the ratio of the Gross intake ratio(%) in Bahamas in 2006 to that in 2010?
Make the answer very short. 1.06. What is the ratio of the Gross intake ratio(%) of Liechtenstein in 2006 to that in 2010?
Offer a terse response. 1.04. What is the ratio of the Gross intake ratio(%) of Ukraine in 2006 to that in 2010?
Provide a succinct answer. 0.89. What is the ratio of the Gross intake ratio(%) of United States in 2006 to that in 2010?
Provide a succinct answer. 1.05. What is the ratio of the Gross intake ratio(%) of Ukraine in 2007 to that in 2008?
Offer a terse response. 0.98. What is the ratio of the Gross intake ratio(%) of United States in 2007 to that in 2008?
Provide a short and direct response. 0.98. What is the ratio of the Gross intake ratio(%) of Bahamas in 2007 to that in 2009?
Your answer should be compact. 0.98. What is the ratio of the Gross intake ratio(%) in Liechtenstein in 2007 to that in 2009?
Your answer should be very brief. 0.82. What is the ratio of the Gross intake ratio(%) in Ukraine in 2007 to that in 2009?
Provide a short and direct response. 0.97. What is the ratio of the Gross intake ratio(%) of United States in 2007 to that in 2009?
Provide a short and direct response. 1.05. What is the ratio of the Gross intake ratio(%) of Bahamas in 2007 to that in 2010?
Offer a very short reply. 1.06. What is the ratio of the Gross intake ratio(%) in Liechtenstein in 2007 to that in 2010?
Ensure brevity in your answer.  1.1. What is the ratio of the Gross intake ratio(%) of Ukraine in 2007 to that in 2010?
Ensure brevity in your answer.  0.91. What is the ratio of the Gross intake ratio(%) of United States in 2007 to that in 2010?
Provide a succinct answer. 1.1. What is the ratio of the Gross intake ratio(%) of Bahamas in 2008 to that in 2009?
Your answer should be very brief. 0.98. What is the ratio of the Gross intake ratio(%) of Liechtenstein in 2008 to that in 2009?
Make the answer very short. 0.82. What is the ratio of the Gross intake ratio(%) of Ukraine in 2008 to that in 2009?
Provide a succinct answer. 0.98. What is the ratio of the Gross intake ratio(%) in United States in 2008 to that in 2009?
Your answer should be very brief. 1.07. What is the ratio of the Gross intake ratio(%) in Bahamas in 2008 to that in 2010?
Ensure brevity in your answer.  1.06. What is the ratio of the Gross intake ratio(%) in Liechtenstein in 2008 to that in 2010?
Ensure brevity in your answer.  1.1. What is the ratio of the Gross intake ratio(%) of Ukraine in 2008 to that in 2010?
Ensure brevity in your answer.  0.92. What is the ratio of the Gross intake ratio(%) in United States in 2008 to that in 2010?
Give a very brief answer. 1.12. What is the ratio of the Gross intake ratio(%) of Bahamas in 2009 to that in 2010?
Provide a short and direct response. 1.09. What is the ratio of the Gross intake ratio(%) in Liechtenstein in 2009 to that in 2010?
Offer a terse response. 1.34. What is the ratio of the Gross intake ratio(%) of Ukraine in 2009 to that in 2010?
Your response must be concise. 0.94. What is the ratio of the Gross intake ratio(%) of United States in 2009 to that in 2010?
Your answer should be very brief. 1.05. What is the difference between the highest and the second highest Gross intake ratio(%) in Bahamas?
Ensure brevity in your answer.  2.72. What is the difference between the highest and the second highest Gross intake ratio(%) of Liechtenstein?
Provide a short and direct response. 23.23. What is the difference between the highest and the second highest Gross intake ratio(%) in Ukraine?
Make the answer very short. 5.72. What is the difference between the highest and the second highest Gross intake ratio(%) of United States?
Ensure brevity in your answer.  1.98. What is the difference between the highest and the lowest Gross intake ratio(%) of Bahamas?
Offer a very short reply. 15.18. What is the difference between the highest and the lowest Gross intake ratio(%) of Liechtenstein?
Your answer should be compact. 38.5. What is the difference between the highest and the lowest Gross intake ratio(%) of Ukraine?
Your answer should be very brief. 12.08. What is the difference between the highest and the lowest Gross intake ratio(%) of United States?
Your answer should be compact. 12.4. 